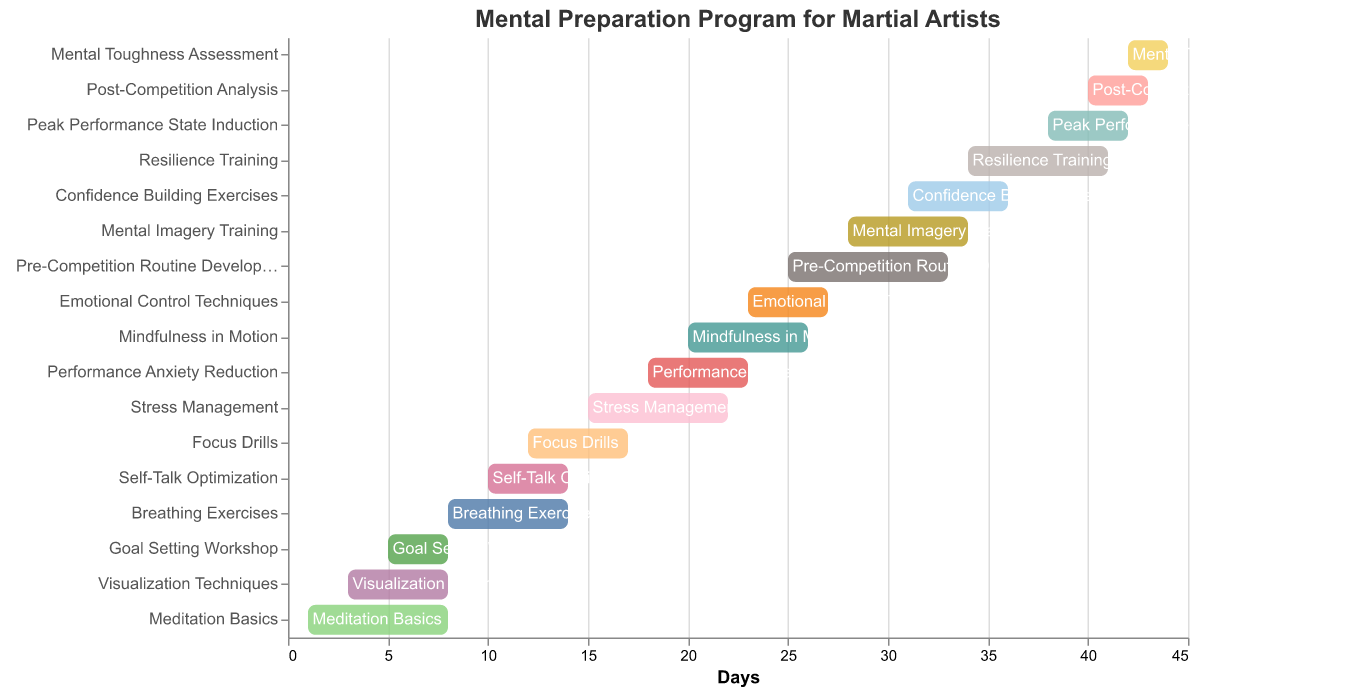What is the title of the Gantt Chart? The title is displayed prominently at the top of the chart. It reads, "Mental Preparation Program for Martial Artists".
Answer: Mental Preparation Program for Martial Artists How many tasks are plotted in the Gantt Chart? By counting the number of distinct tasks listed on the y-axis, we can see that there are 17 tasks.
Answer: 17 Which task starts first in the mental preparation program? Looking at the x-axis (Days) and finding the task that starts at the earliest day, "Meditation Basics" starts on Day 1.
Answer: Meditation Basics Which task has the longest duration? By comparing the duration of all tasks, we can see that "Pre-Competition Routine Development" has the longest duration with 8 days.
Answer: Pre-Competition Routine Development Between "Breathing Exercises" and "Focus Drills," which task starts earlier, and by how many days? "Breathing Exercises" starts on Day 8, while "Focus Drills" starts on Day 12. By subtracting 8 from 12, we find that "Breathing Exercises" starts 4 days earlier.
Answer: Breathing Exercises; 4 days How many days into the program does the final task, "Mental Toughness Assessment," end? The "Mental Toughness Assessment" task starts on Day 42 and lasts for 2 days. Adding these two numbers together (42 + 2), the task ends on Day 44.
Answer: Day 44 What is the total duration of "Mindfulness in Motion" combined with "Emotional Control Techniques"? "Mindfulness in Motion" has a duration of 6 days and "Emotional Control Techniques" has a duration of 4 days. Adding them together gives a total duration of 10 days.
Answer: 10 days Which tasks are overlapping on Day 6? "Meditation Basics" starts on Day 1 (duration: 7 days) and "Visualization Techniques" starts on Day 3 (duration: 5 days). Both cover Day 6 as their durations overlap.
Answer: Meditation Basics and Visualization Techniques How many tasks start after Day 20? Looking at the x-axis starting points after Day 20, the tasks are "Emotional Control Techniques", "Pre-Competition Routine Development", "Mental Imagery Training", "Confidence Building Exercises", "Resilience Training", "Peak Performance State Induction", "Post-Competition Analysis", and "Mental Toughness Assessment." There are 8 tasks.
Answer: 8 tasks Which tasks have the same duration of 4 days? By looking at the duration column, the tasks "Self-Talk Optimization," "Emotional Control Techniques," and "Peak Performance State Induction" all have a duration of 4 days.
Answer: Self-Talk Optimization, Emotional Control Techniques, Peak Performance State Induction 